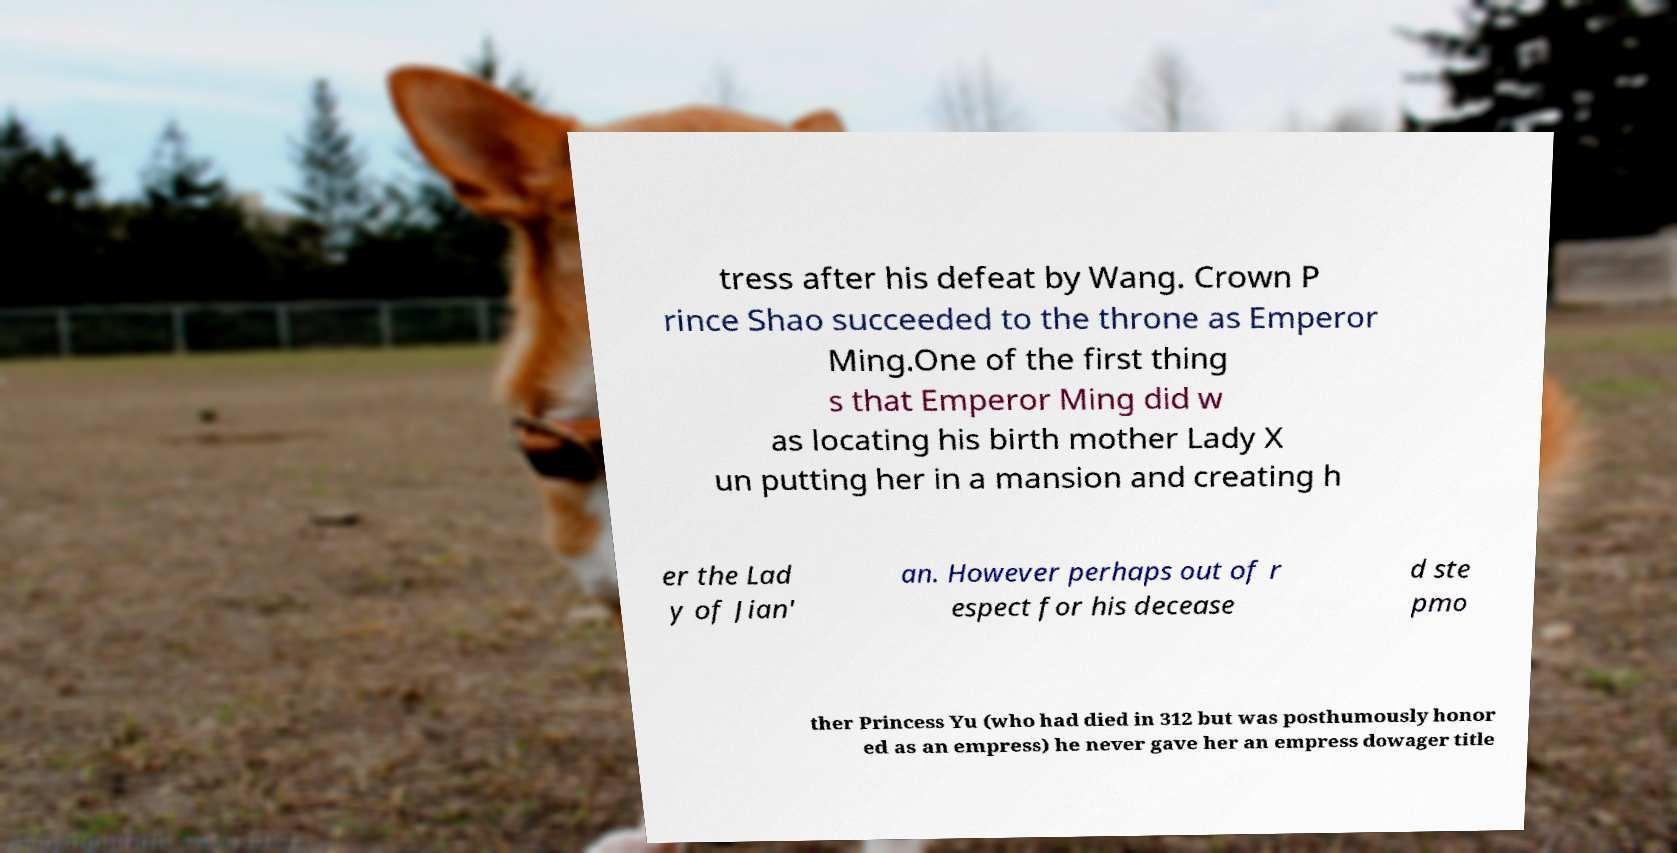Can you read and provide the text displayed in the image?This photo seems to have some interesting text. Can you extract and type it out for me? tress after his defeat by Wang. Crown P rince Shao succeeded to the throne as Emperor Ming.One of the first thing s that Emperor Ming did w as locating his birth mother Lady X un putting her in a mansion and creating h er the Lad y of Jian' an. However perhaps out of r espect for his decease d ste pmo ther Princess Yu (who had died in 312 but was posthumously honor ed as an empress) he never gave her an empress dowager title 